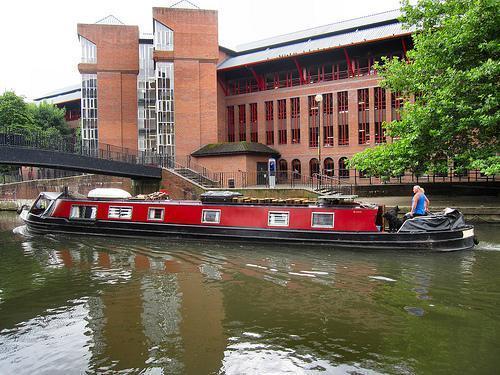How many people are pictured?
Give a very brief answer. 1. 